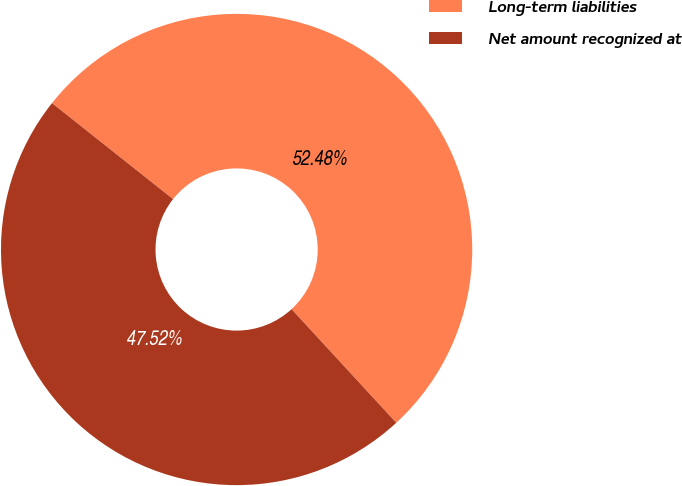<chart> <loc_0><loc_0><loc_500><loc_500><pie_chart><fcel>Long-term liabilities<fcel>Net amount recognized at<nl><fcel>52.48%<fcel>47.52%<nl></chart> 